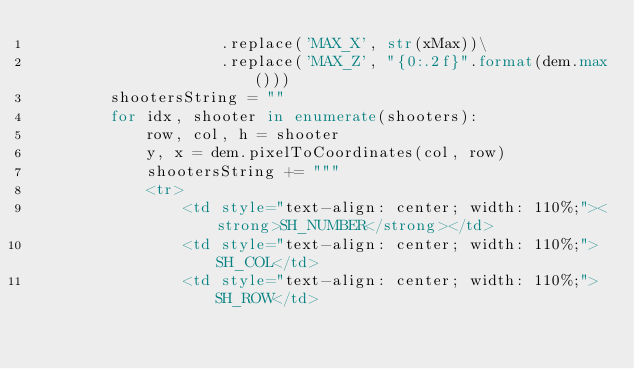<code> <loc_0><loc_0><loc_500><loc_500><_Python_>                    .replace('MAX_X', str(xMax))\
                    .replace('MAX_Z', "{0:.2f}".format(dem.max()))
        shootersString = ""
        for idx, shooter in enumerate(shooters):
            row, col, h = shooter
            y, x = dem.pixelToCoordinates(col, row)
            shootersString += """
            <tr>
                <td style="text-align: center; width: 110%;"><strong>SH_NUMBER</strong></td>
                <td style="text-align: center; width: 110%;">SH_COL</td>
                <td style="text-align: center; width: 110%;">SH_ROW</td></code> 